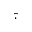<formula> <loc_0><loc_0><loc_500><loc_500>\hat { \cdot }</formula> 